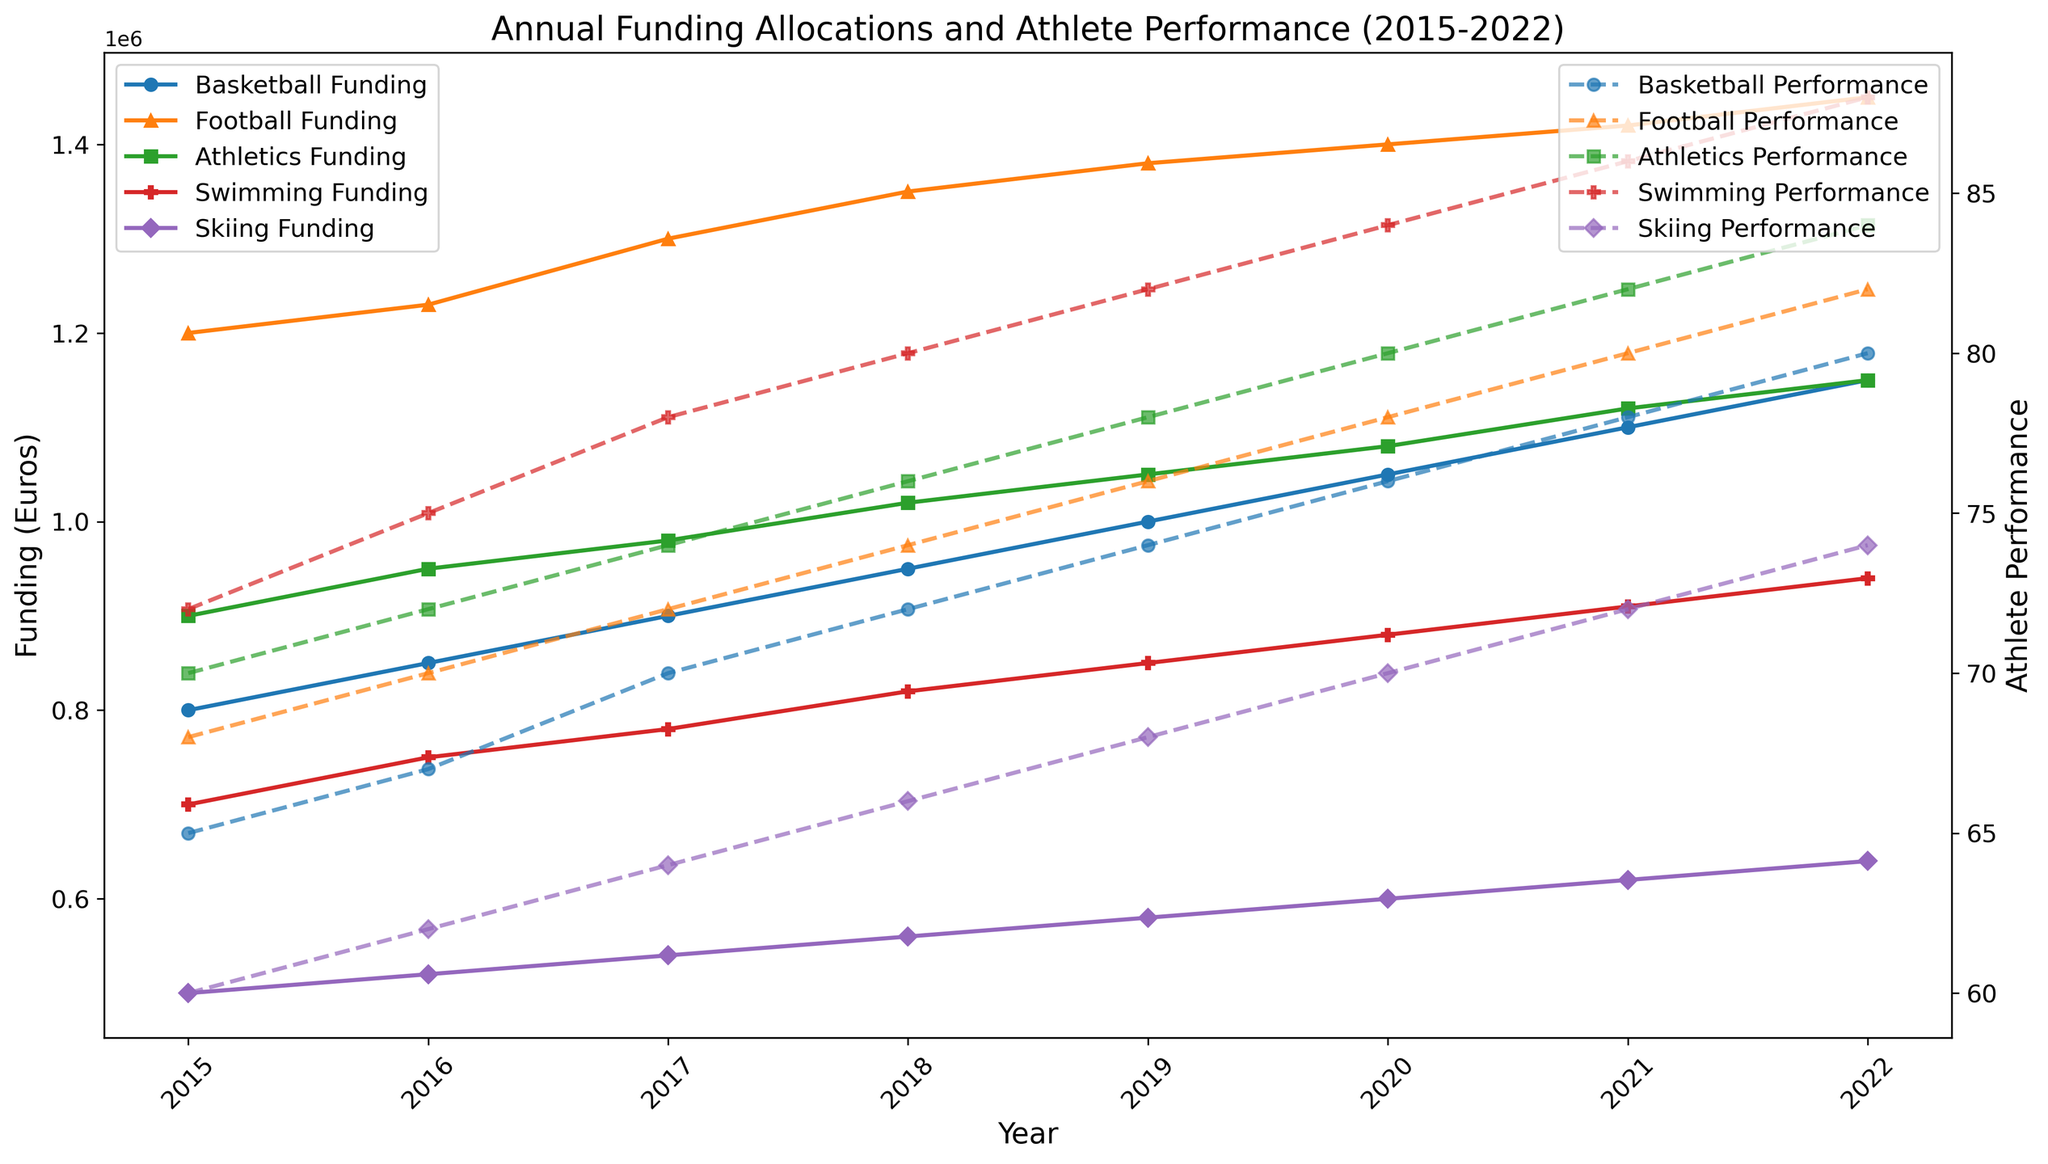Which sport received the highest annual funding in 2020? By observing the line that reaches the highest point on the left y-axis for the year 2020, we can see that Football Funding is the highest.
Answer: Football How did the total funding for all sports in 2017 compare to 2015? First, sum the funding for all sports in 2017: 900,000 (Basketball) + 1,300,000 (Football) + 980,000 (Athletics) + 780,000 (Swimming) + 540,000 (Skiing) = 4,500,000. Sum the funding for all sports in 2015: 800,000 + 1,200,000 + 900,000 + 700,000 + 500,000 = 4,100,000. The difference is 4,500,000 - 4,100,000 = 400,000.
Answer: 400,000 Which sport's athletes' performance showed the greatest improvement from 2015 to 2022? By examining the trend lines on the right y-axis, we note the initial and final performance values: Basketball (65 to 80), Football (68 to 82), Athletics (70 to 84), Swimming (72 to 88), Skiing (60 to 74). The greatest improvement is for Swimming, which improved by 88 - 72 = 16 points.
Answer: Swimming In which year did Basketball funding surpass 1,000,000 euros? By observing the line representing Basketball Funding that crosses the 1,000,000 mark on the left y-axis, we notice that it occurs in the year 2019.
Answer: 2019 Did Swimming get more funding or better athlete performance in 2018? By looking at the funding and performance lines for Swimming in 2018, we see that the funding was 820,000 euros, and the athlete performance was 80. Comparing these numbers directly, the performance value (80) is higher relative to its standard range.
Answer: Better athlete performance What's the average annual funding for Football from 2015 to 2022? Sum the football funding values from 2015 to 2022: 1,200,000 + 1,230,000 + 1,300,000 + 1,350,000 + 1,380,000 + 1,400,000 + 1,420,000 + 1,450,000 = 10,730,000. Then, divide by the number of years (8): 10,730,000 / 8 = 1,341,250.
Answer: 1,341,250 Which sport had steady funding increments every year from 2015 to 2022? By observing the funding trend lines, we notice that the Basketball Funding line increases steadily every year without any dips or plateaus.
Answer: Basketball How did the performance of Athletics athletes change between 2016 and 2018? Look at the Athletics Athletes Performance line between the years 2016 and 2018: it started at 72 in 2016 and moved up to 76 in 2018, showing a consistent increase by 4 points over those two years.
Answer: Increase by 4 points What's the percentage increase in Skiing funding from 2015 to 2022? Skiing funding in 2015 was 500,000 and in 2022 it was 640,000. The increase is 640,000 - 500,000 = 140,000. The percentage increase is (140,000 / 500,000) * 100 = 28%.
Answer: 28% 